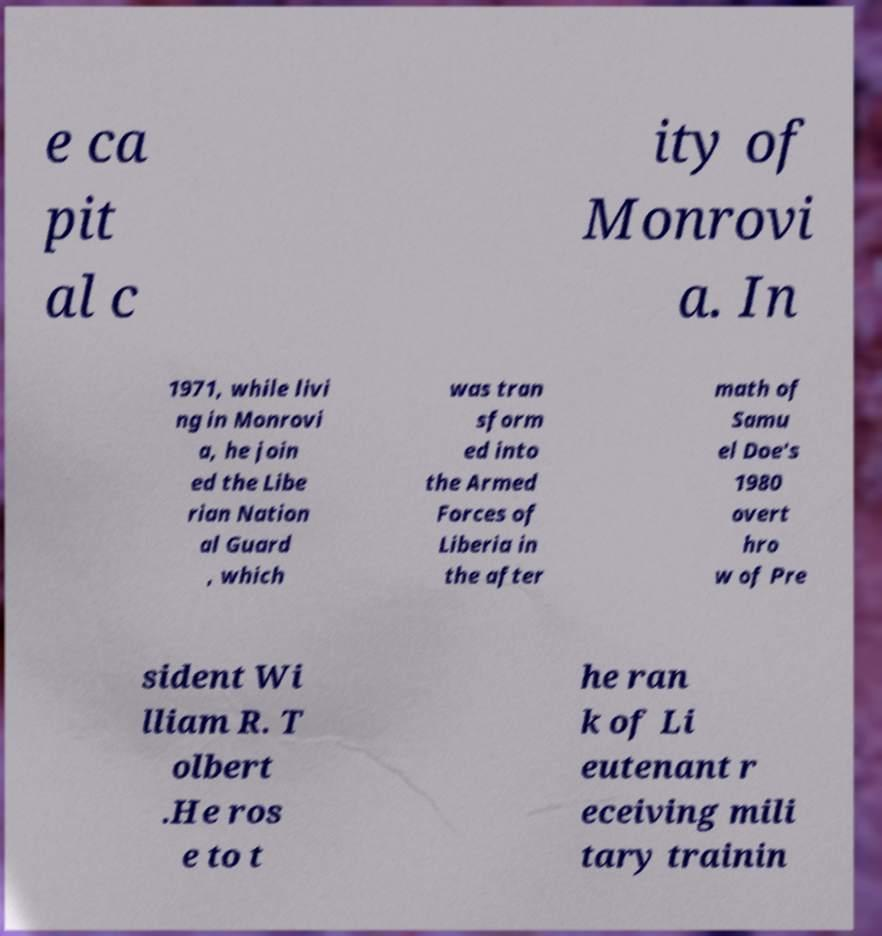Can you read and provide the text displayed in the image?This photo seems to have some interesting text. Can you extract and type it out for me? e ca pit al c ity of Monrovi a. In 1971, while livi ng in Monrovi a, he join ed the Libe rian Nation al Guard , which was tran sform ed into the Armed Forces of Liberia in the after math of Samu el Doe's 1980 overt hro w of Pre sident Wi lliam R. T olbert .He ros e to t he ran k of Li eutenant r eceiving mili tary trainin 